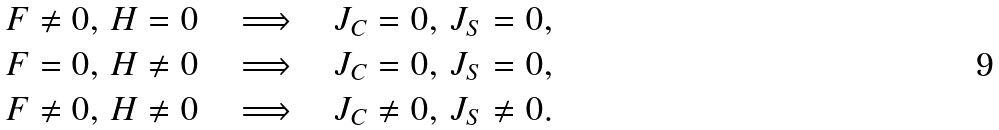<formula> <loc_0><loc_0><loc_500><loc_500>& F \neq 0 , \, H = 0 \quad \Longrightarrow \quad J _ { C } = 0 , \, J _ { S } = 0 , \\ & F = 0 , \, H \neq 0 \quad \Longrightarrow \quad J _ { C } = 0 , \, J _ { S } = 0 , \\ & F \neq 0 , \, H \neq 0 \quad \Longrightarrow \quad J _ { C } \neq 0 , \, J _ { S } \neq 0 .</formula> 